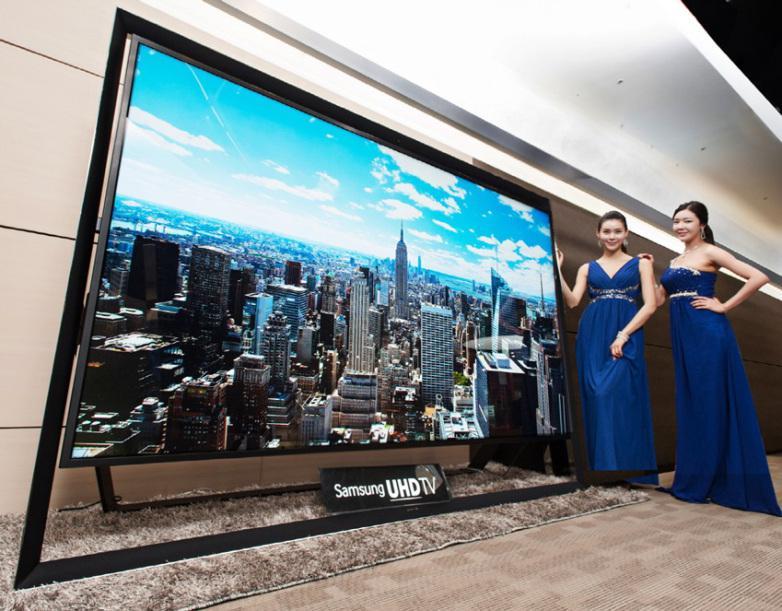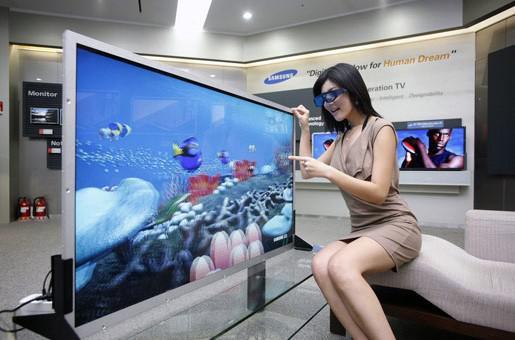The first image is the image on the left, the second image is the image on the right. For the images displayed, is the sentence "In at least one image there is a woman standing to the right of a TV display showing it." factually correct? Answer yes or no. Yes. The first image is the image on the left, the second image is the image on the right. For the images displayed, is the sentence "In one image, one woman has one hand at the top of a big-screen TV and is gesturing toward it with the other hand." factually correct? Answer yes or no. Yes. 